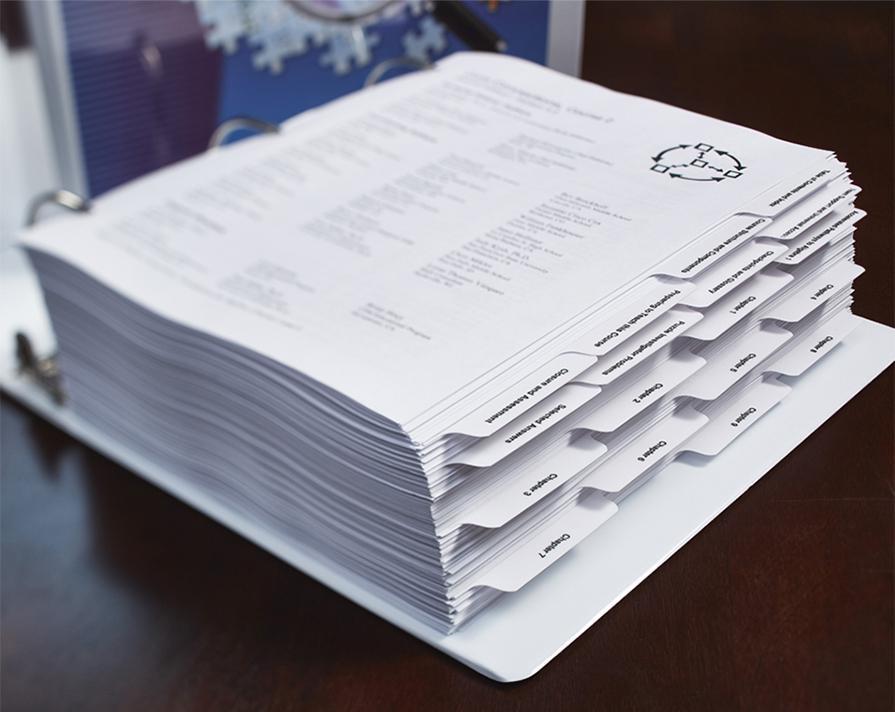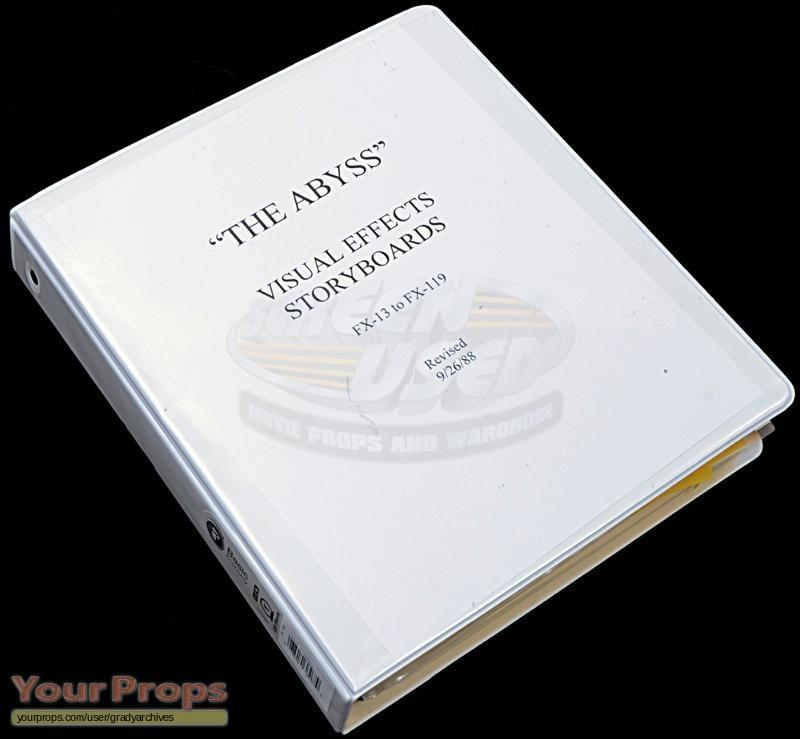The first image is the image on the left, the second image is the image on the right. Assess this claim about the two images: "One of the binders is full and has dividers tabs.". Correct or not? Answer yes or no. Yes. The first image is the image on the left, the second image is the image on the right. Considering the images on both sides, is "One of the binders is white and closed." valid? Answer yes or no. Yes. 